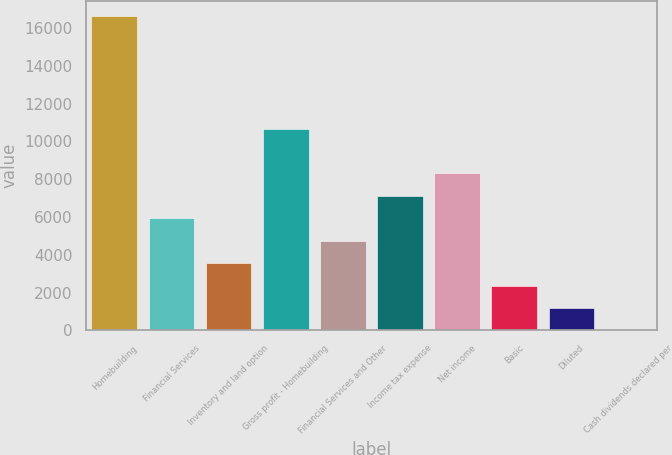<chart> <loc_0><loc_0><loc_500><loc_500><bar_chart><fcel>Homebuilding<fcel>Financial Services<fcel>Inventory and land option<fcel>Gross profit - Homebuilding<fcel>Financial Services and Other<fcel>Income tax expense<fcel>Net income<fcel>Basic<fcel>Diluted<fcel>Cash dividends declared per<nl><fcel>16606.4<fcel>5931.07<fcel>3558.77<fcel>10675.7<fcel>4744.92<fcel>7117.22<fcel>8303.37<fcel>2372.62<fcel>1186.47<fcel>0.32<nl></chart> 